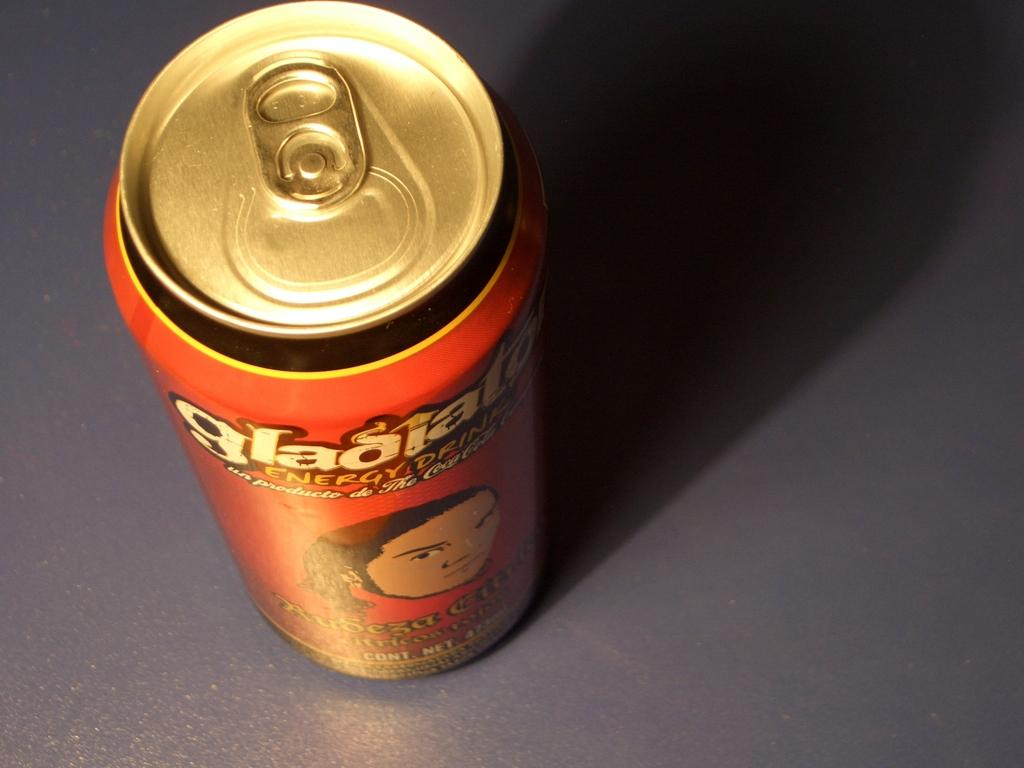<image>
Relay a brief, clear account of the picture shown. The word energy is displayed on the can. 